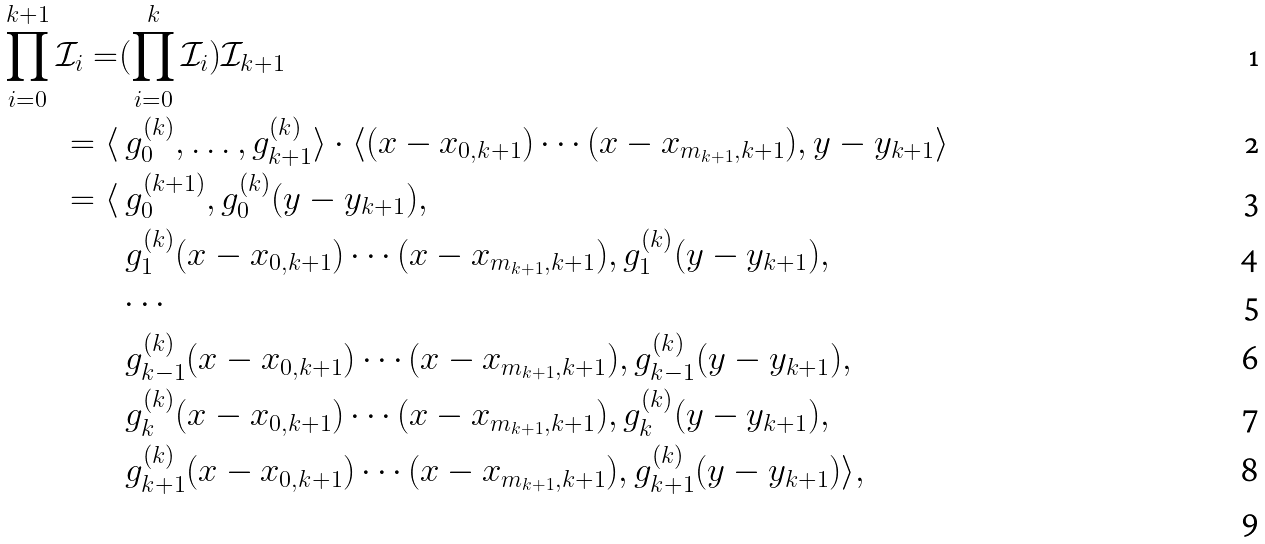Convert formula to latex. <formula><loc_0><loc_0><loc_500><loc_500>\prod _ { i = 0 } ^ { k + 1 } \mathcal { I } _ { i } = & ( \prod _ { i = 0 } ^ { k } \mathcal { I } _ { i } ) \mathcal { I } _ { k + 1 } \\ = \langle & \ g _ { 0 } ^ { ( k ) } , \dots , g _ { k + 1 } ^ { ( k ) } \rangle \cdot \langle ( x - x _ { 0 , k + 1 } ) \cdots ( x - x _ { m _ { k + 1 } , k + 1 } ) , y - y _ { k + 1 } \rangle \\ = \langle & \ g _ { 0 } ^ { ( k + 1 ) } , g _ { 0 } ^ { ( k ) } ( y - y _ { k + 1 } ) , \\ & \ g _ { 1 } ^ { ( k ) } ( x - x _ { 0 , k + 1 } ) \cdots ( x - x _ { m _ { k + 1 } , k + 1 } ) , g _ { 1 } ^ { ( k ) } ( y - y _ { k + 1 } ) , \\ & \cdots \\ & \ g _ { k - 1 } ^ { ( k ) } ( x - x _ { 0 , k + 1 } ) \cdots ( x - x _ { m _ { k + 1 } , k + 1 } ) , g _ { k - 1 } ^ { ( k ) } ( y - y _ { k + 1 } ) , \\ & \ g _ { k } ^ { ( k ) } ( x - x _ { 0 , k + 1 } ) \cdots ( x - x _ { m _ { k + 1 } , k + 1 } ) , g _ { k } ^ { ( k ) } ( y - y _ { k + 1 } ) , \\ & \ g _ { k + 1 } ^ { ( k ) } ( x - x _ { 0 , k + 1 } ) \cdots ( x - x _ { m _ { k + 1 } , k + 1 } ) , g _ { k + 1 } ^ { ( k ) } ( y - y _ { k + 1 } ) \rangle , \\</formula> 